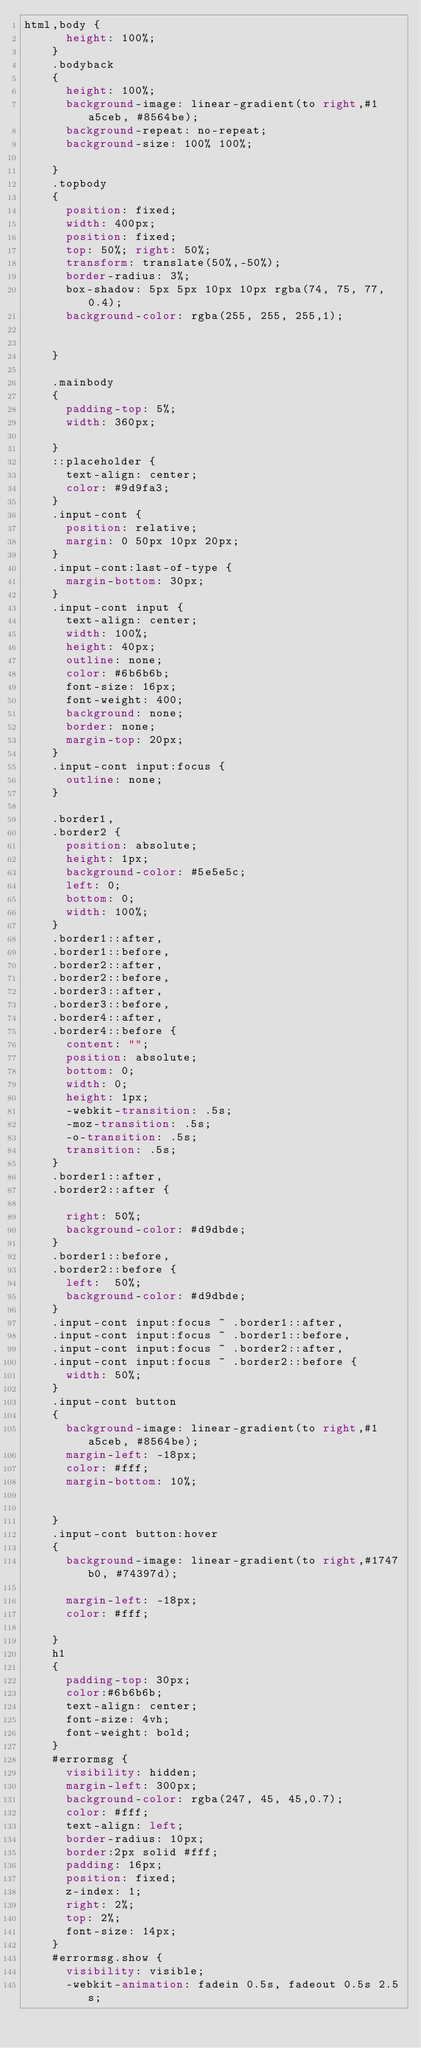<code> <loc_0><loc_0><loc_500><loc_500><_CSS_>html,body {
			height: 100%;
		}
		.bodyback
		{      
			height: 100%;
			background-image: linear-gradient(to right,#1a5ceb, #8564be);
			background-repeat: no-repeat;
			background-size: 100% 100%;

		}
		.topbody
		{
			position: fixed;
			width: 400px;
			position: fixed;			
			top: 50%; right: 50%;
			transform: translate(50%,-50%);
			border-radius: 3%;
			box-shadow: 5px 5px 10px 10px rgba(74, 75, 77, 0.4);
			background-color: rgba(255, 255, 255,1);


		}

		.mainbody
		{
			padding-top: 5%;       
			width: 360px;

		}
		::placeholder {
			text-align: center;
			color: #9d9fa3;
		}
		.input-cont {
			position: relative;
			margin: 0 50px 10px 20px;
		}
		.input-cont:last-of-type {
			margin-bottom: 30px;
		}
		.input-cont input {
			text-align: center;
			width: 100%;
			height: 40px;
			outline: none;
			color: #6b6b6b;
			font-size: 16px;
			font-weight: 400;
			background: none;
			border: none;
			margin-top: 20px;
		}
		.input-cont input:focus {
			outline: none;
		}

		.border1,
		.border2 {
			position: absolute;
			height: 1px;
			background-color: #5e5e5c;
			left: 0;
			bottom: 0;
			width: 100%;
		}
		.border1::after,
		.border1::before,
		.border2::after,
		.border2::before,
		.border3::after,
		.border3::before,
		.border4::after,
		.border4::before {
			content: "";
			position: absolute;
			bottom: 0;
			width: 0;
			height: 1px;
			-webkit-transition: .5s;
			-moz-transition: .5s;
			-o-transition: .5s;
			transition: .5s;
		}
		.border1::after,
		.border2::after {

			right: 50%;
			background-color: #d9dbde;
		}
		.border1::before,
		.border2::before {
			left:  50%;
			background-color: #d9dbde;
		}
		.input-cont input:focus ~ .border1::after,
		.input-cont input:focus ~ .border1::before,
		.input-cont input:focus ~ .border2::after,
		.input-cont input:focus ~ .border2::before {
			width: 50%;
		}
		.input-cont button
		{
			background-image: linear-gradient(to right,#1a5ceb, #8564be);
			margin-left: -18px;
			color: #fff;
			margin-bottom: 10%;


		}
		.input-cont button:hover
		{
			background-image: linear-gradient(to right,#1747b0, #74397d);

			margin-left: -18px;
			color: #fff;

		}
		h1
		{
			padding-top: 30px;
			color:#6b6b6b;
			text-align: center;
			font-size: 4vh;
			font-weight: bold;
		}
		#errormsg {
			visibility: hidden;
			margin-left: 300px;
			background-color: rgba(247, 45, 45,0.7);
			color: #fff;
			text-align: left;
			border-radius: 10px;
			border:2px solid #fff;
			padding: 16px;
			position: fixed;
			z-index: 1;
			right: 2%;
			top: 2%;
			font-size: 14px;
		}
		#errormsg.show {
			visibility: visible;
			-webkit-animation: fadein 0.5s, fadeout 0.5s 2.5s;</code> 